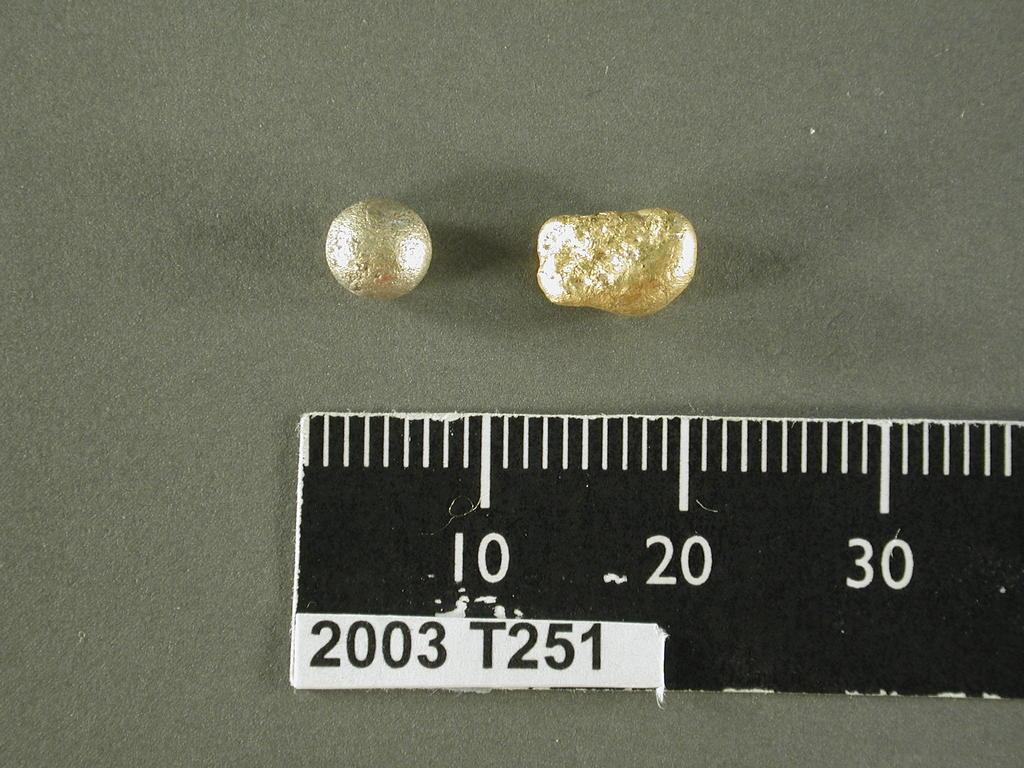<image>
Relay a brief, clear account of the picture shown. Appears to be tiny gold nuggets being measured against a ruler that says 2003 T251. 